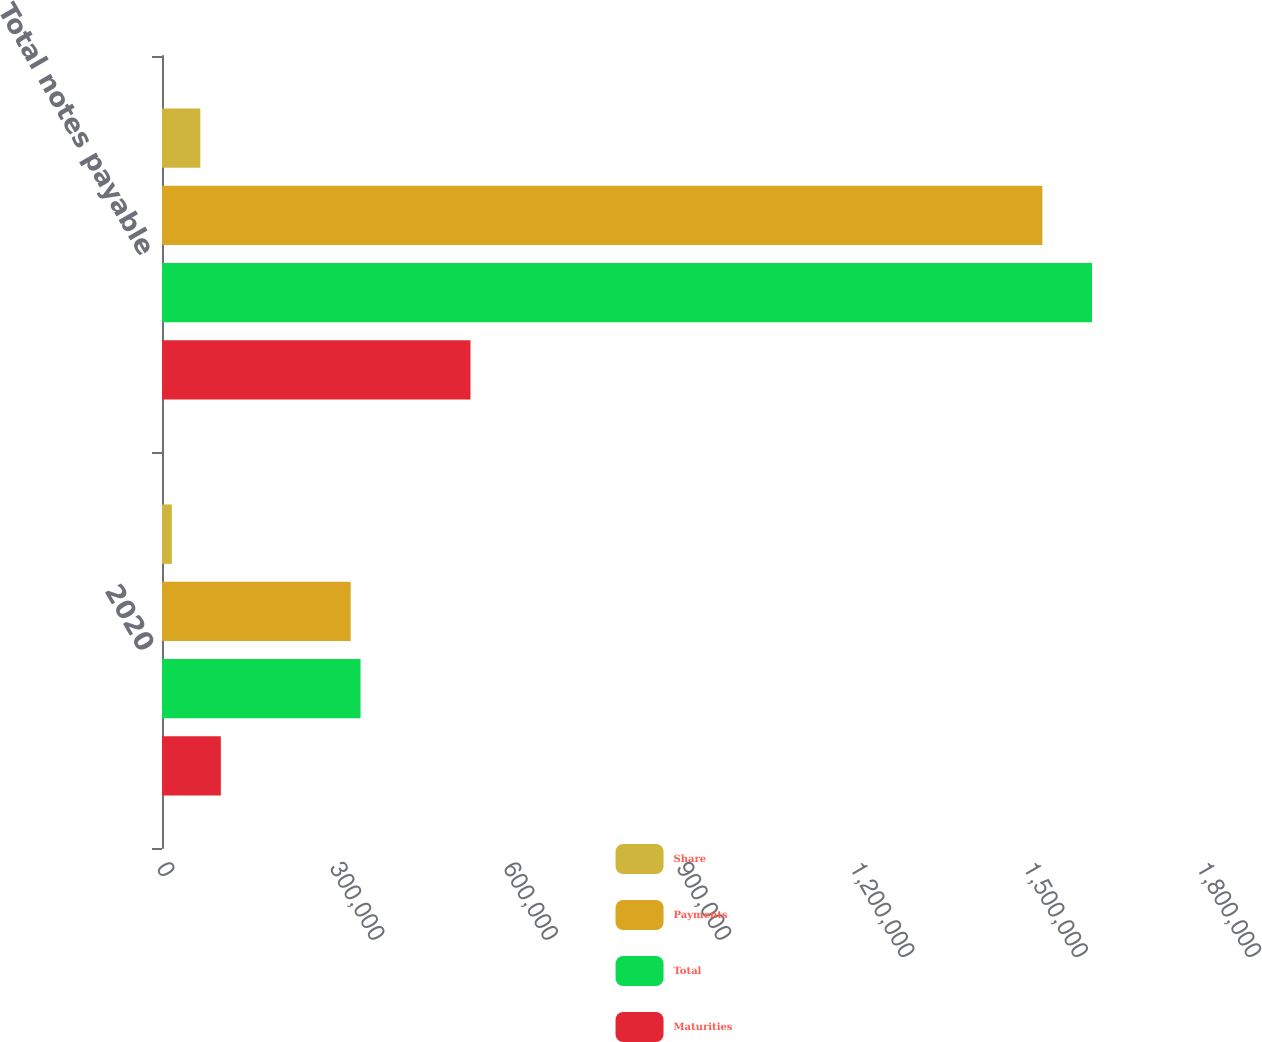<chart> <loc_0><loc_0><loc_500><loc_500><stacked_bar_chart><ecel><fcel>2020<fcel>Total notes payable<nl><fcel>Share<fcel>17043<fcel>66306<nl><fcel>Payments<fcel>326583<fcel>1.52371e+06<nl><fcel>Total<fcel>343626<fcel>1.60965e+06<nl><fcel>Maturities<fcel>101841<fcel>533973<nl></chart> 